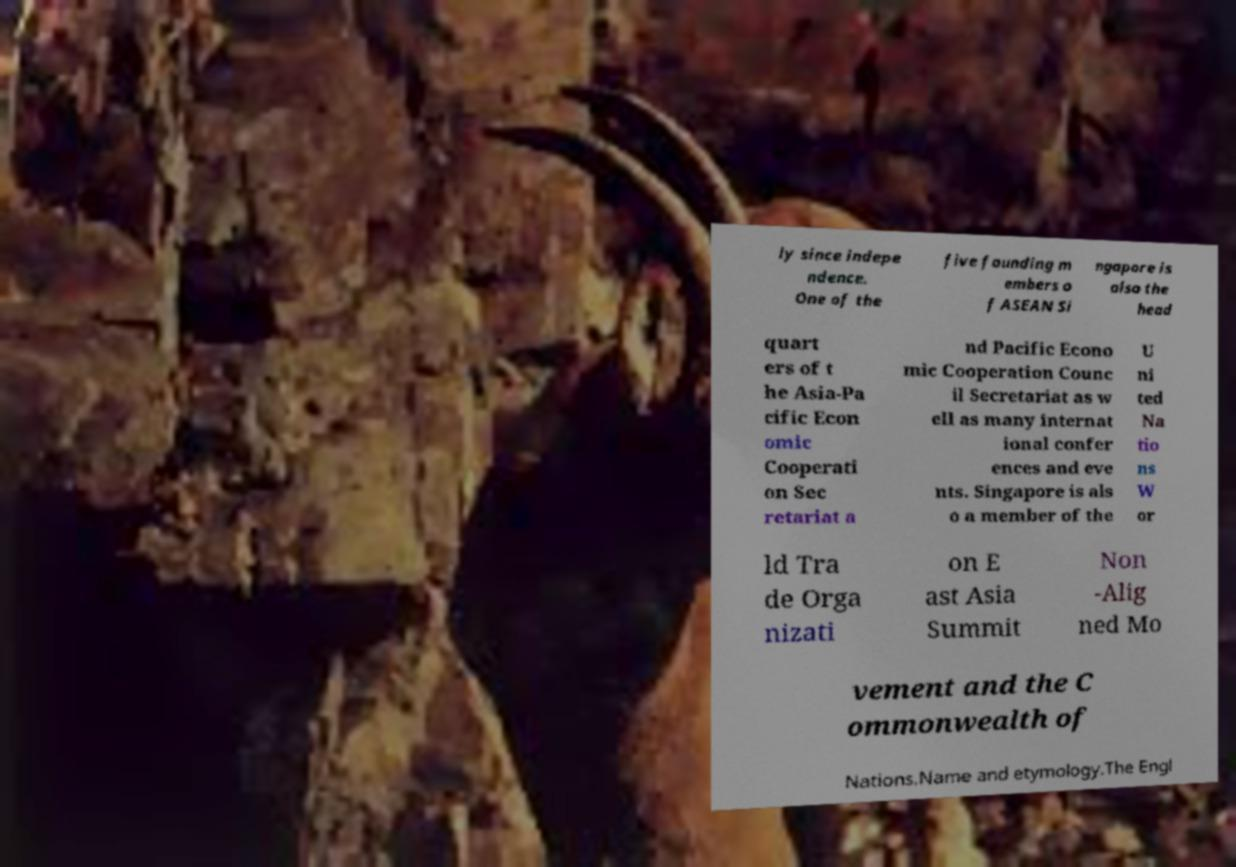Can you accurately transcribe the text from the provided image for me? ly since indepe ndence. One of the five founding m embers o f ASEAN Si ngapore is also the head quart ers of t he Asia-Pa cific Econ omic Cooperati on Sec retariat a nd Pacific Econo mic Cooperation Counc il Secretariat as w ell as many internat ional confer ences and eve nts. Singapore is als o a member of the U ni ted Na tio ns W or ld Tra de Orga nizati on E ast Asia Summit Non -Alig ned Mo vement and the C ommonwealth of Nations.Name and etymology.The Engl 